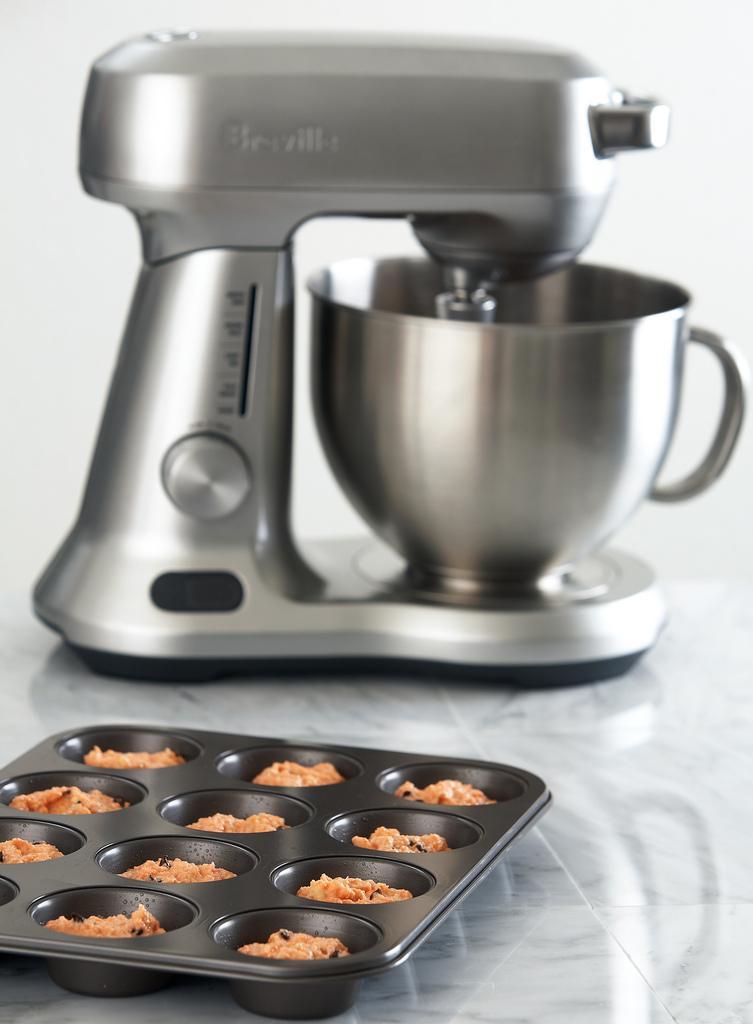How would you summarize this image in a sentence or two? In the foreground of this image, there are cookies in a black tray and in the background, there is a mixer is on the stone surface. 